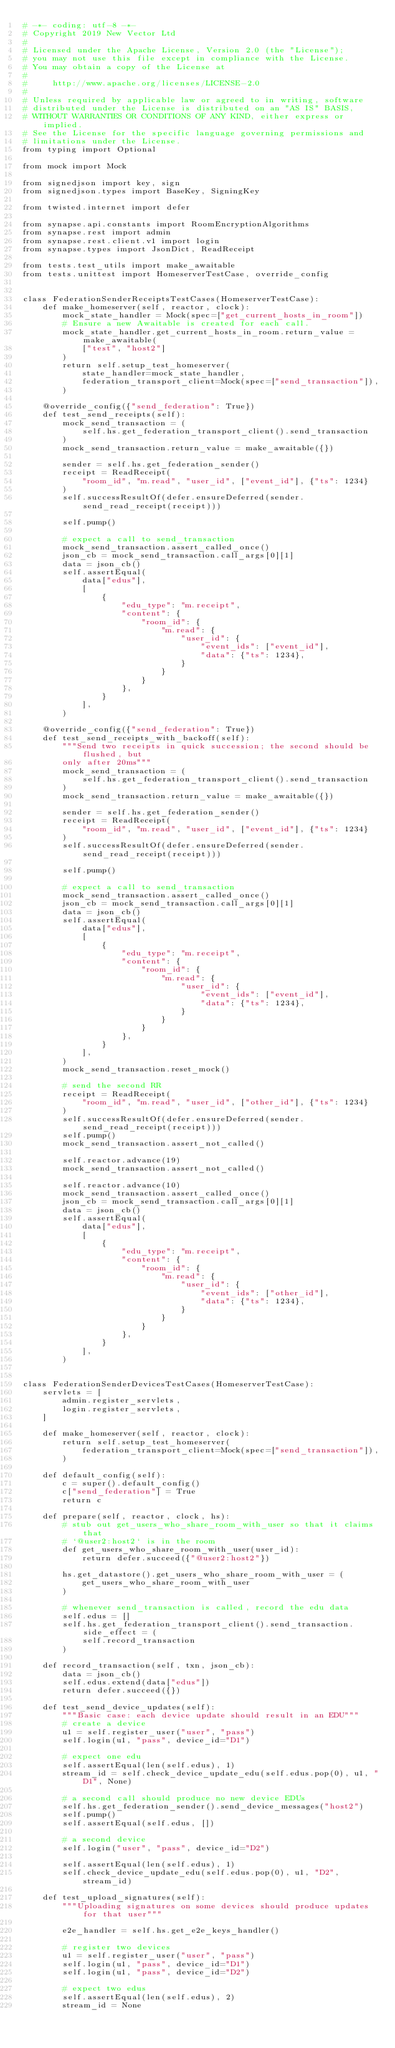<code> <loc_0><loc_0><loc_500><loc_500><_Python_># -*- coding: utf-8 -*-
# Copyright 2019 New Vector Ltd
#
# Licensed under the Apache License, Version 2.0 (the "License");
# you may not use this file except in compliance with the License.
# You may obtain a copy of the License at
#
#     http://www.apache.org/licenses/LICENSE-2.0
#
# Unless required by applicable law or agreed to in writing, software
# distributed under the License is distributed on an "AS IS" BASIS,
# WITHOUT WARRANTIES OR CONDITIONS OF ANY KIND, either express or implied.
# See the License for the specific language governing permissions and
# limitations under the License.
from typing import Optional

from mock import Mock

from signedjson import key, sign
from signedjson.types import BaseKey, SigningKey

from twisted.internet import defer

from synapse.api.constants import RoomEncryptionAlgorithms
from synapse.rest import admin
from synapse.rest.client.v1 import login
from synapse.types import JsonDict, ReadReceipt

from tests.test_utils import make_awaitable
from tests.unittest import HomeserverTestCase, override_config


class FederationSenderReceiptsTestCases(HomeserverTestCase):
    def make_homeserver(self, reactor, clock):
        mock_state_handler = Mock(spec=["get_current_hosts_in_room"])
        # Ensure a new Awaitable is created for each call.
        mock_state_handler.get_current_hosts_in_room.return_value = make_awaitable(
            ["test", "host2"]
        )
        return self.setup_test_homeserver(
            state_handler=mock_state_handler,
            federation_transport_client=Mock(spec=["send_transaction"]),
        )

    @override_config({"send_federation": True})
    def test_send_receipts(self):
        mock_send_transaction = (
            self.hs.get_federation_transport_client().send_transaction
        )
        mock_send_transaction.return_value = make_awaitable({})

        sender = self.hs.get_federation_sender()
        receipt = ReadReceipt(
            "room_id", "m.read", "user_id", ["event_id"], {"ts": 1234}
        )
        self.successResultOf(defer.ensureDeferred(sender.send_read_receipt(receipt)))

        self.pump()

        # expect a call to send_transaction
        mock_send_transaction.assert_called_once()
        json_cb = mock_send_transaction.call_args[0][1]
        data = json_cb()
        self.assertEqual(
            data["edus"],
            [
                {
                    "edu_type": "m.receipt",
                    "content": {
                        "room_id": {
                            "m.read": {
                                "user_id": {
                                    "event_ids": ["event_id"],
                                    "data": {"ts": 1234},
                                }
                            }
                        }
                    },
                }
            ],
        )

    @override_config({"send_federation": True})
    def test_send_receipts_with_backoff(self):
        """Send two receipts in quick succession; the second should be flushed, but
        only after 20ms"""
        mock_send_transaction = (
            self.hs.get_federation_transport_client().send_transaction
        )
        mock_send_transaction.return_value = make_awaitable({})

        sender = self.hs.get_federation_sender()
        receipt = ReadReceipt(
            "room_id", "m.read", "user_id", ["event_id"], {"ts": 1234}
        )
        self.successResultOf(defer.ensureDeferred(sender.send_read_receipt(receipt)))

        self.pump()

        # expect a call to send_transaction
        mock_send_transaction.assert_called_once()
        json_cb = mock_send_transaction.call_args[0][1]
        data = json_cb()
        self.assertEqual(
            data["edus"],
            [
                {
                    "edu_type": "m.receipt",
                    "content": {
                        "room_id": {
                            "m.read": {
                                "user_id": {
                                    "event_ids": ["event_id"],
                                    "data": {"ts": 1234},
                                }
                            }
                        }
                    },
                }
            ],
        )
        mock_send_transaction.reset_mock()

        # send the second RR
        receipt = ReadReceipt(
            "room_id", "m.read", "user_id", ["other_id"], {"ts": 1234}
        )
        self.successResultOf(defer.ensureDeferred(sender.send_read_receipt(receipt)))
        self.pump()
        mock_send_transaction.assert_not_called()

        self.reactor.advance(19)
        mock_send_transaction.assert_not_called()

        self.reactor.advance(10)
        mock_send_transaction.assert_called_once()
        json_cb = mock_send_transaction.call_args[0][1]
        data = json_cb()
        self.assertEqual(
            data["edus"],
            [
                {
                    "edu_type": "m.receipt",
                    "content": {
                        "room_id": {
                            "m.read": {
                                "user_id": {
                                    "event_ids": ["other_id"],
                                    "data": {"ts": 1234},
                                }
                            }
                        }
                    },
                }
            ],
        )


class FederationSenderDevicesTestCases(HomeserverTestCase):
    servlets = [
        admin.register_servlets,
        login.register_servlets,
    ]

    def make_homeserver(self, reactor, clock):
        return self.setup_test_homeserver(
            federation_transport_client=Mock(spec=["send_transaction"]),
        )

    def default_config(self):
        c = super().default_config()
        c["send_federation"] = True
        return c

    def prepare(self, reactor, clock, hs):
        # stub out get_users_who_share_room_with_user so that it claims that
        # `@user2:host2` is in the room
        def get_users_who_share_room_with_user(user_id):
            return defer.succeed({"@user2:host2"})

        hs.get_datastore().get_users_who_share_room_with_user = (
            get_users_who_share_room_with_user
        )

        # whenever send_transaction is called, record the edu data
        self.edus = []
        self.hs.get_federation_transport_client().send_transaction.side_effect = (
            self.record_transaction
        )

    def record_transaction(self, txn, json_cb):
        data = json_cb()
        self.edus.extend(data["edus"])
        return defer.succeed({})

    def test_send_device_updates(self):
        """Basic case: each device update should result in an EDU"""
        # create a device
        u1 = self.register_user("user", "pass")
        self.login(u1, "pass", device_id="D1")

        # expect one edu
        self.assertEqual(len(self.edus), 1)
        stream_id = self.check_device_update_edu(self.edus.pop(0), u1, "D1", None)

        # a second call should produce no new device EDUs
        self.hs.get_federation_sender().send_device_messages("host2")
        self.pump()
        self.assertEqual(self.edus, [])

        # a second device
        self.login("user", "pass", device_id="D2")

        self.assertEqual(len(self.edus), 1)
        self.check_device_update_edu(self.edus.pop(0), u1, "D2", stream_id)

    def test_upload_signatures(self):
        """Uploading signatures on some devices should produce updates for that user"""

        e2e_handler = self.hs.get_e2e_keys_handler()

        # register two devices
        u1 = self.register_user("user", "pass")
        self.login(u1, "pass", device_id="D1")
        self.login(u1, "pass", device_id="D2")

        # expect two edus
        self.assertEqual(len(self.edus), 2)
        stream_id = None</code> 